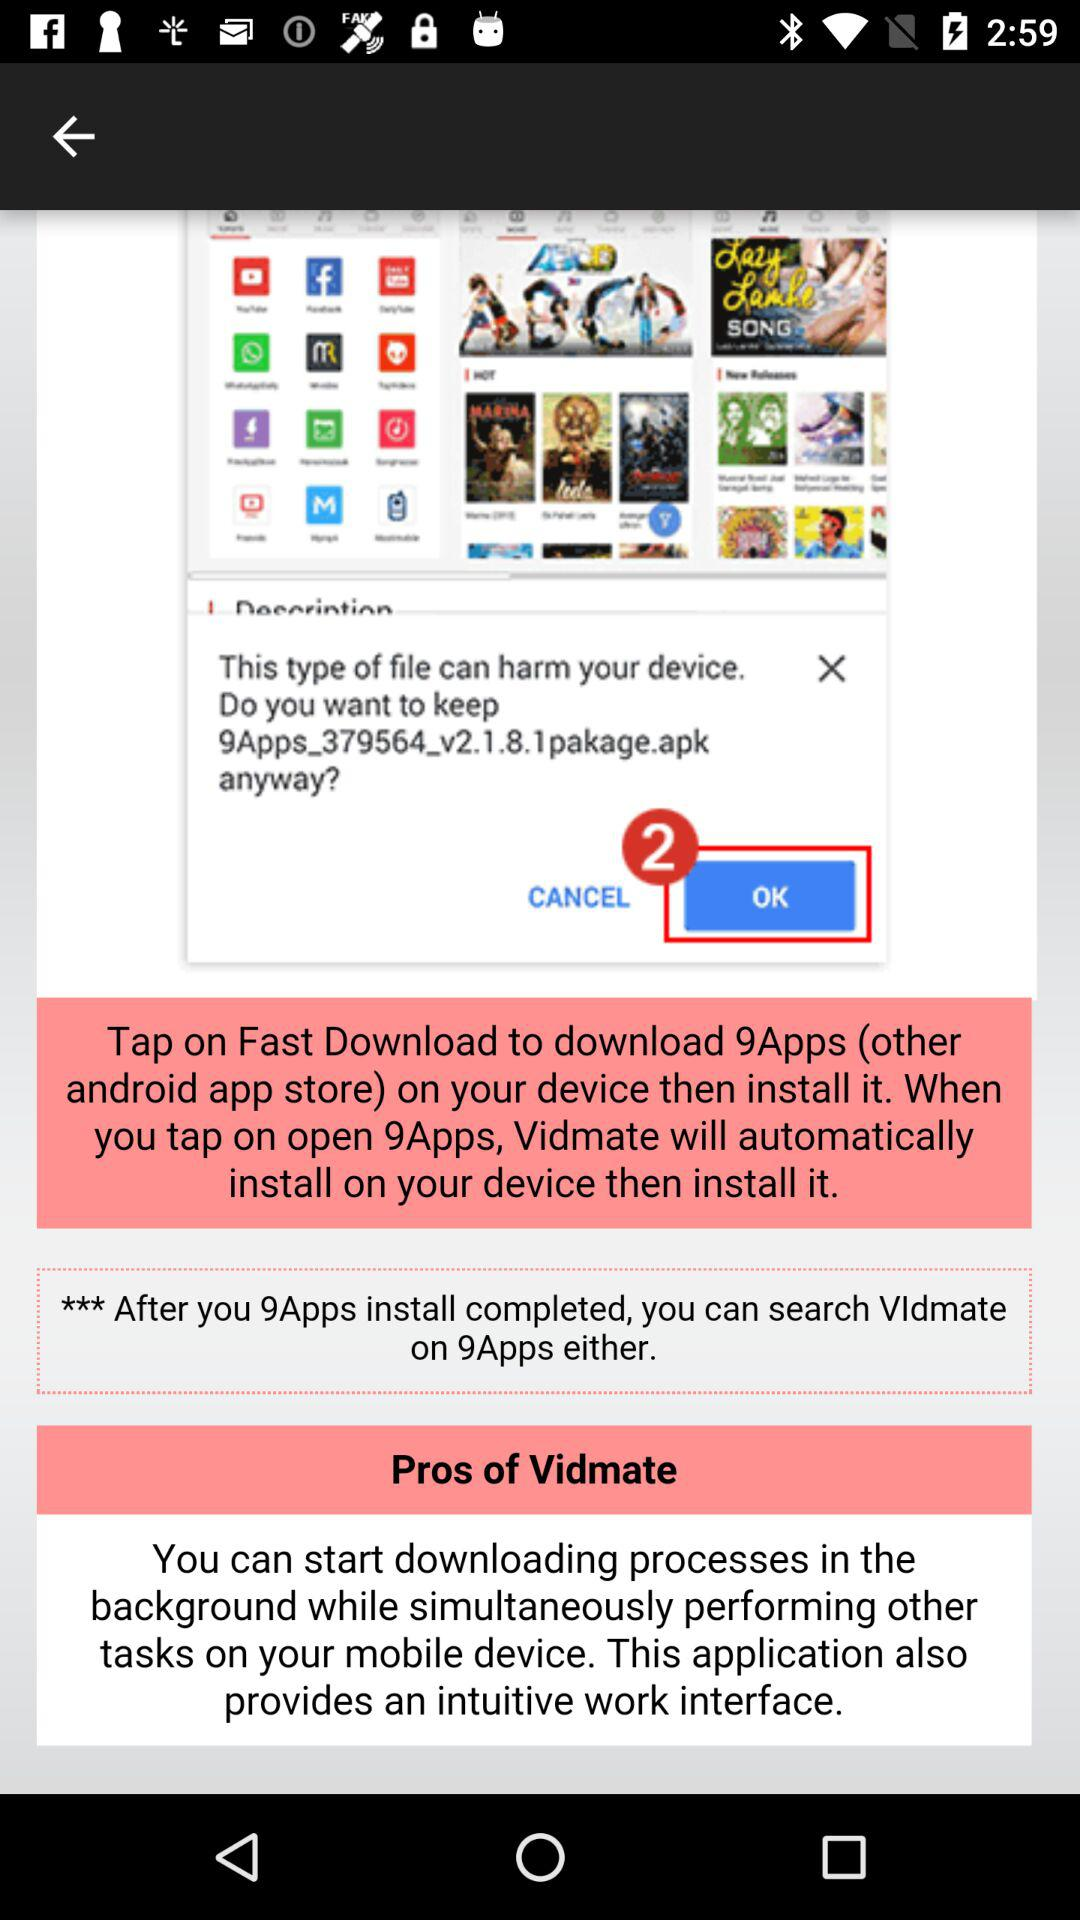On "9Apps", which app can we search for? On "9Apps", you can search for "Vldmate". 